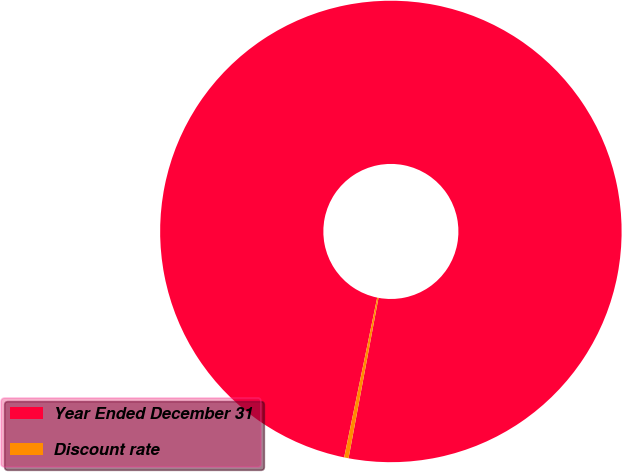Convert chart. <chart><loc_0><loc_0><loc_500><loc_500><pie_chart><fcel>Year Ended December 31<fcel>Discount rate<nl><fcel>99.69%<fcel>0.31%<nl></chart> 